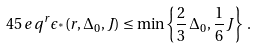<formula> <loc_0><loc_0><loc_500><loc_500>4 5 \, e \, q ^ { r } \epsilon _ { ^ { * } } ( r , \Delta _ { 0 } , J ) \leq \min \left \{ \frac { 2 } { 3 } \, \Delta _ { 0 } , \frac { 1 } { 6 } \, J \right \} \, .</formula> 